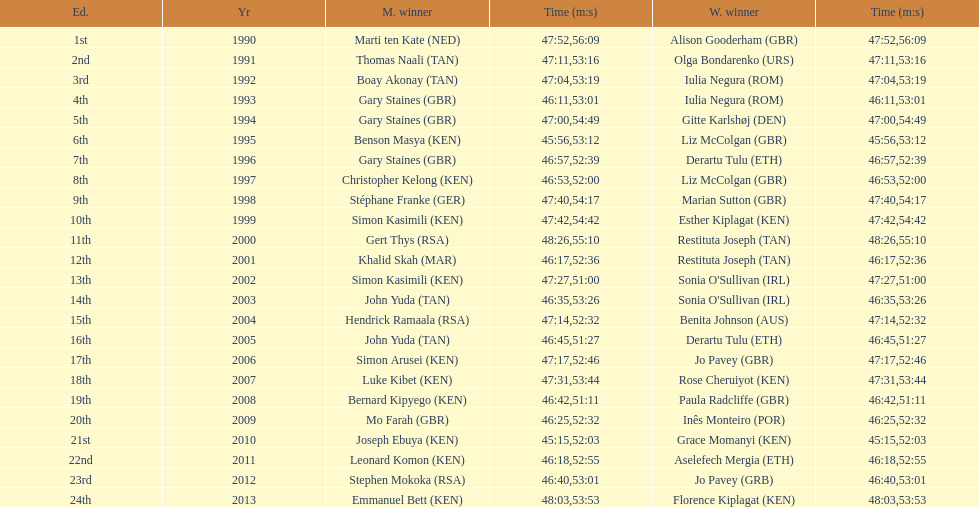Parse the full table. {'header': ['Ed.', 'Yr', 'M. winner', 'Time (m:s)', 'W. winner', 'Time (m:s)'], 'rows': [['1st', '1990', 'Marti ten Kate\xa0(NED)', '47:52', 'Alison Gooderham\xa0(GBR)', '56:09'], ['2nd', '1991', 'Thomas Naali\xa0(TAN)', '47:11', 'Olga Bondarenko\xa0(URS)', '53:16'], ['3rd', '1992', 'Boay Akonay\xa0(TAN)', '47:04', 'Iulia Negura\xa0(ROM)', '53:19'], ['4th', '1993', 'Gary Staines\xa0(GBR)', '46:11', 'Iulia Negura\xa0(ROM)', '53:01'], ['5th', '1994', 'Gary Staines\xa0(GBR)', '47:00', 'Gitte Karlshøj\xa0(DEN)', '54:49'], ['6th', '1995', 'Benson Masya\xa0(KEN)', '45:56', 'Liz McColgan\xa0(GBR)', '53:12'], ['7th', '1996', 'Gary Staines\xa0(GBR)', '46:57', 'Derartu Tulu\xa0(ETH)', '52:39'], ['8th', '1997', 'Christopher Kelong\xa0(KEN)', '46:53', 'Liz McColgan\xa0(GBR)', '52:00'], ['9th', '1998', 'Stéphane Franke\xa0(GER)', '47:40', 'Marian Sutton\xa0(GBR)', '54:17'], ['10th', '1999', 'Simon Kasimili\xa0(KEN)', '47:42', 'Esther Kiplagat\xa0(KEN)', '54:42'], ['11th', '2000', 'Gert Thys\xa0(RSA)', '48:26', 'Restituta Joseph\xa0(TAN)', '55:10'], ['12th', '2001', 'Khalid Skah\xa0(MAR)', '46:17', 'Restituta Joseph\xa0(TAN)', '52:36'], ['13th', '2002', 'Simon Kasimili\xa0(KEN)', '47:27', "Sonia O'Sullivan\xa0(IRL)", '51:00'], ['14th', '2003', 'John Yuda\xa0(TAN)', '46:35', "Sonia O'Sullivan\xa0(IRL)", '53:26'], ['15th', '2004', 'Hendrick Ramaala\xa0(RSA)', '47:14', 'Benita Johnson\xa0(AUS)', '52:32'], ['16th', '2005', 'John Yuda\xa0(TAN)', '46:45', 'Derartu Tulu\xa0(ETH)', '51:27'], ['17th', '2006', 'Simon Arusei\xa0(KEN)', '47:17', 'Jo Pavey\xa0(GBR)', '52:46'], ['18th', '2007', 'Luke Kibet\xa0(KEN)', '47:31', 'Rose Cheruiyot\xa0(KEN)', '53:44'], ['19th', '2008', 'Bernard Kipyego\xa0(KEN)', '46:42', 'Paula Radcliffe\xa0(GBR)', '51:11'], ['20th', '2009', 'Mo Farah\xa0(GBR)', '46:25', 'Inês Monteiro\xa0(POR)', '52:32'], ['21st', '2010', 'Joseph Ebuya\xa0(KEN)', '45:15', 'Grace Momanyi\xa0(KEN)', '52:03'], ['22nd', '2011', 'Leonard Komon\xa0(KEN)', '46:18', 'Aselefech Mergia\xa0(ETH)', '52:55'], ['23rd', '2012', 'Stephen Mokoka\xa0(RSA)', '46:40', 'Jo Pavey\xa0(GRB)', '53:01'], ['24th', '2013', 'Emmanuel Bett\xa0(KEN)', '48:03', 'Florence Kiplagat\xa0(KEN)', '53:53']]} What is the name of the first women's winner? Alison Gooderham. 